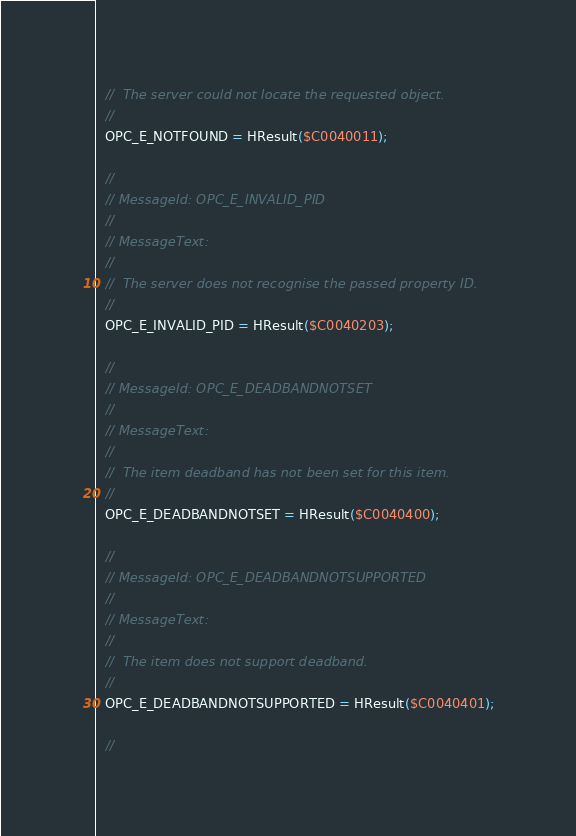Convert code to text. <code><loc_0><loc_0><loc_500><loc_500><_Pascal_>  //  The server could not locate the requested object.
  //
  OPC_E_NOTFOUND = HResult($C0040011);

  //
  // MessageId: OPC_E_INVALID_PID
  //
  // MessageText:
  //
  //  The server does not recognise the passed property ID.
  //
  OPC_E_INVALID_PID = HResult($C0040203);

  //
  // MessageId: OPC_E_DEADBANDNOTSET
  //
  // MessageText:
  //
  //  The item deadband has not been set for this item.
  //
  OPC_E_DEADBANDNOTSET = HResult($C0040400);

  //
  // MessageId: OPC_E_DEADBANDNOTSUPPORTED
  //
  // MessageText:
  //
  //  The item does not support deadband.
  //
  OPC_E_DEADBANDNOTSUPPORTED = HResult($C0040401);

  //</code> 